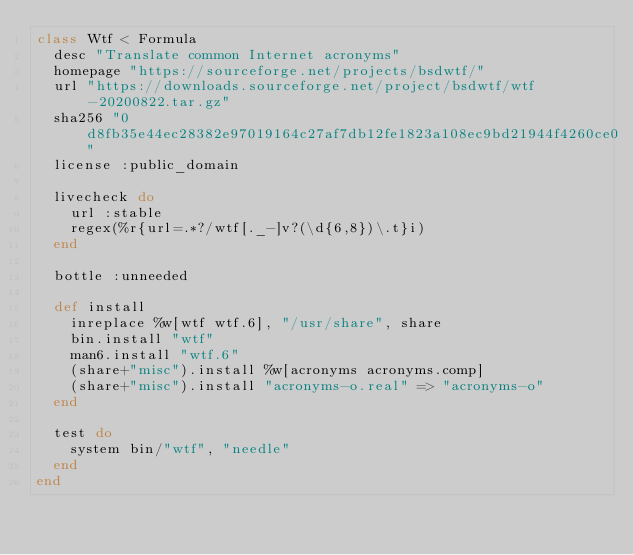Convert code to text. <code><loc_0><loc_0><loc_500><loc_500><_Ruby_>class Wtf < Formula
  desc "Translate common Internet acronyms"
  homepage "https://sourceforge.net/projects/bsdwtf/"
  url "https://downloads.sourceforge.net/project/bsdwtf/wtf-20200822.tar.gz"
  sha256 "0d8fb35e44ec28382e97019164c27af7db12fe1823a108ec9bd21944f4260ce0"
  license :public_domain

  livecheck do
    url :stable
    regex(%r{url=.*?/wtf[._-]v?(\d{6,8})\.t}i)
  end

  bottle :unneeded

  def install
    inreplace %w[wtf wtf.6], "/usr/share", share
    bin.install "wtf"
    man6.install "wtf.6"
    (share+"misc").install %w[acronyms acronyms.comp]
    (share+"misc").install "acronyms-o.real" => "acronyms-o"
  end

  test do
    system bin/"wtf", "needle"
  end
end
</code> 